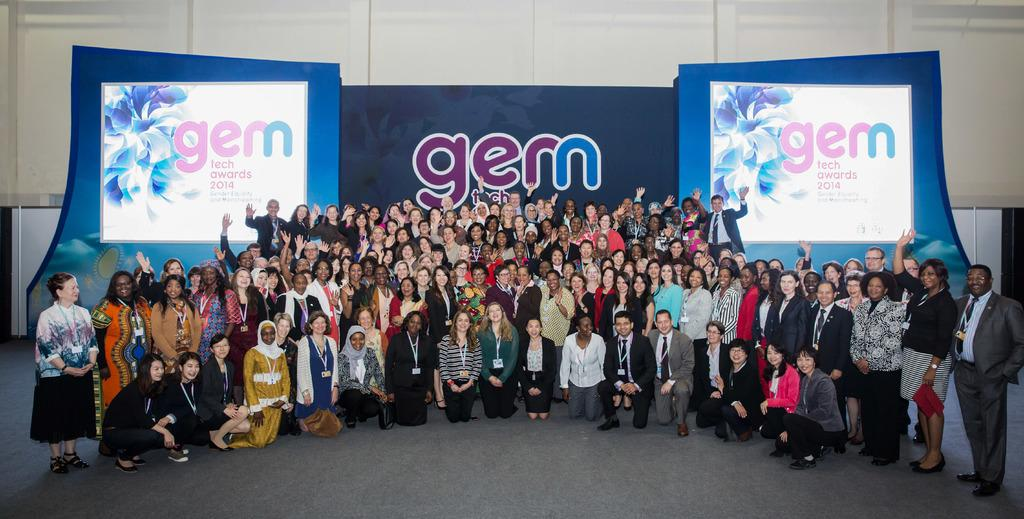How many people are in the image? There is a group of people in the image, but the exact number is not specified. What can be seen in the background of the image? There is a screen with projected text in the background of the image. What type of pig is being used as an attraction in the image? There is no pig present in the image, nor is there any indication of an attraction. 